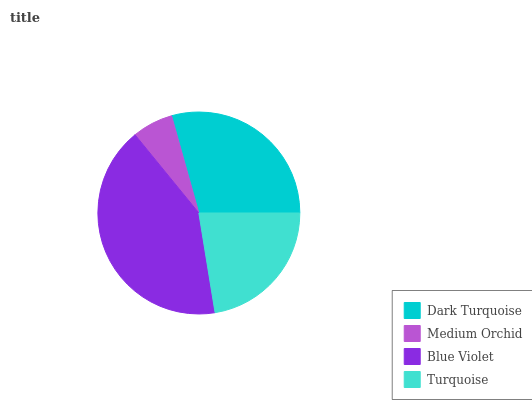Is Medium Orchid the minimum?
Answer yes or no. Yes. Is Blue Violet the maximum?
Answer yes or no. Yes. Is Blue Violet the minimum?
Answer yes or no. No. Is Medium Orchid the maximum?
Answer yes or no. No. Is Blue Violet greater than Medium Orchid?
Answer yes or no. Yes. Is Medium Orchid less than Blue Violet?
Answer yes or no. Yes. Is Medium Orchid greater than Blue Violet?
Answer yes or no. No. Is Blue Violet less than Medium Orchid?
Answer yes or no. No. Is Dark Turquoise the high median?
Answer yes or no. Yes. Is Turquoise the low median?
Answer yes or no. Yes. Is Medium Orchid the high median?
Answer yes or no. No. Is Blue Violet the low median?
Answer yes or no. No. 